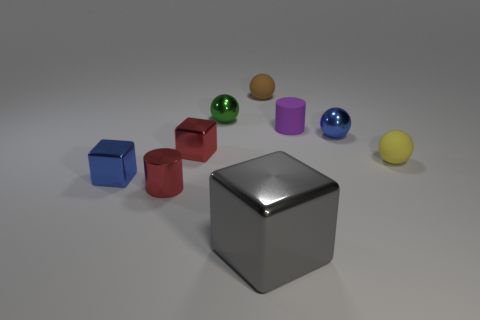Is there anything else that has the same size as the gray metallic block?
Keep it short and to the point. No. Is the big object the same color as the matte cylinder?
Provide a short and direct response. No. What number of tiny red metallic things are there?
Offer a very short reply. 2. There is a cylinder on the right side of the red metal object that is behind the tiny red cylinder; what is it made of?
Ensure brevity in your answer.  Rubber. There is a red cube that is the same size as the yellow rubber object; what material is it?
Offer a very short reply. Metal. Is the size of the red object that is behind the yellow sphere the same as the big object?
Provide a succinct answer. No. Does the blue metallic thing that is to the right of the large gray block have the same shape as the gray object?
Keep it short and to the point. No. What number of things are blue spheres or rubber spheres that are behind the red block?
Keep it short and to the point. 2. Are there fewer tiny brown matte balls than red rubber cylinders?
Keep it short and to the point. No. Are there more red shiny cylinders than tiny matte spheres?
Keep it short and to the point. No. 